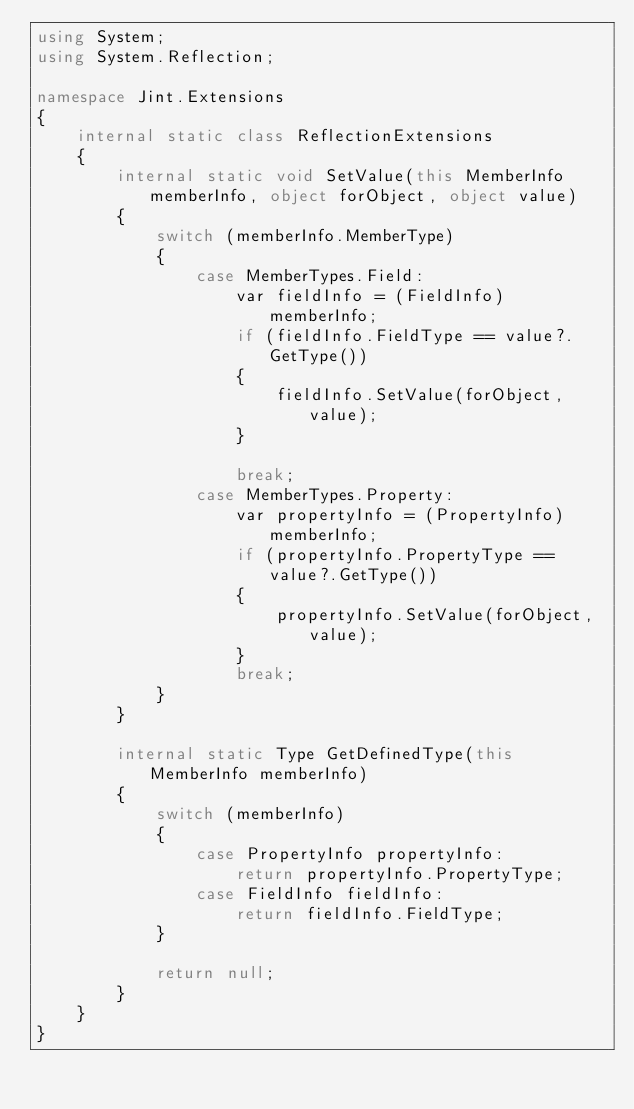Convert code to text. <code><loc_0><loc_0><loc_500><loc_500><_C#_>using System;
using System.Reflection;

namespace Jint.Extensions
{
    internal static class ReflectionExtensions
    {
        internal static void SetValue(this MemberInfo memberInfo, object forObject, object value)
        {
            switch (memberInfo.MemberType)
            {
                case MemberTypes.Field:
                    var fieldInfo = (FieldInfo) memberInfo;
                    if (fieldInfo.FieldType == value?.GetType())
                    {
                        fieldInfo.SetValue(forObject, value);
                    }

                    break;
                case MemberTypes.Property:
                    var propertyInfo = (PropertyInfo) memberInfo;
                    if (propertyInfo.PropertyType == value?.GetType())
                    {
                        propertyInfo.SetValue(forObject, value);
                    }
                    break;
            }
        }

        internal static Type GetDefinedType(this MemberInfo memberInfo)
        {
            switch (memberInfo)
            {
                case PropertyInfo propertyInfo:
                    return propertyInfo.PropertyType;
                case FieldInfo fieldInfo:
                    return fieldInfo.FieldType;
            }

            return null;
        }
    }
}
</code> 